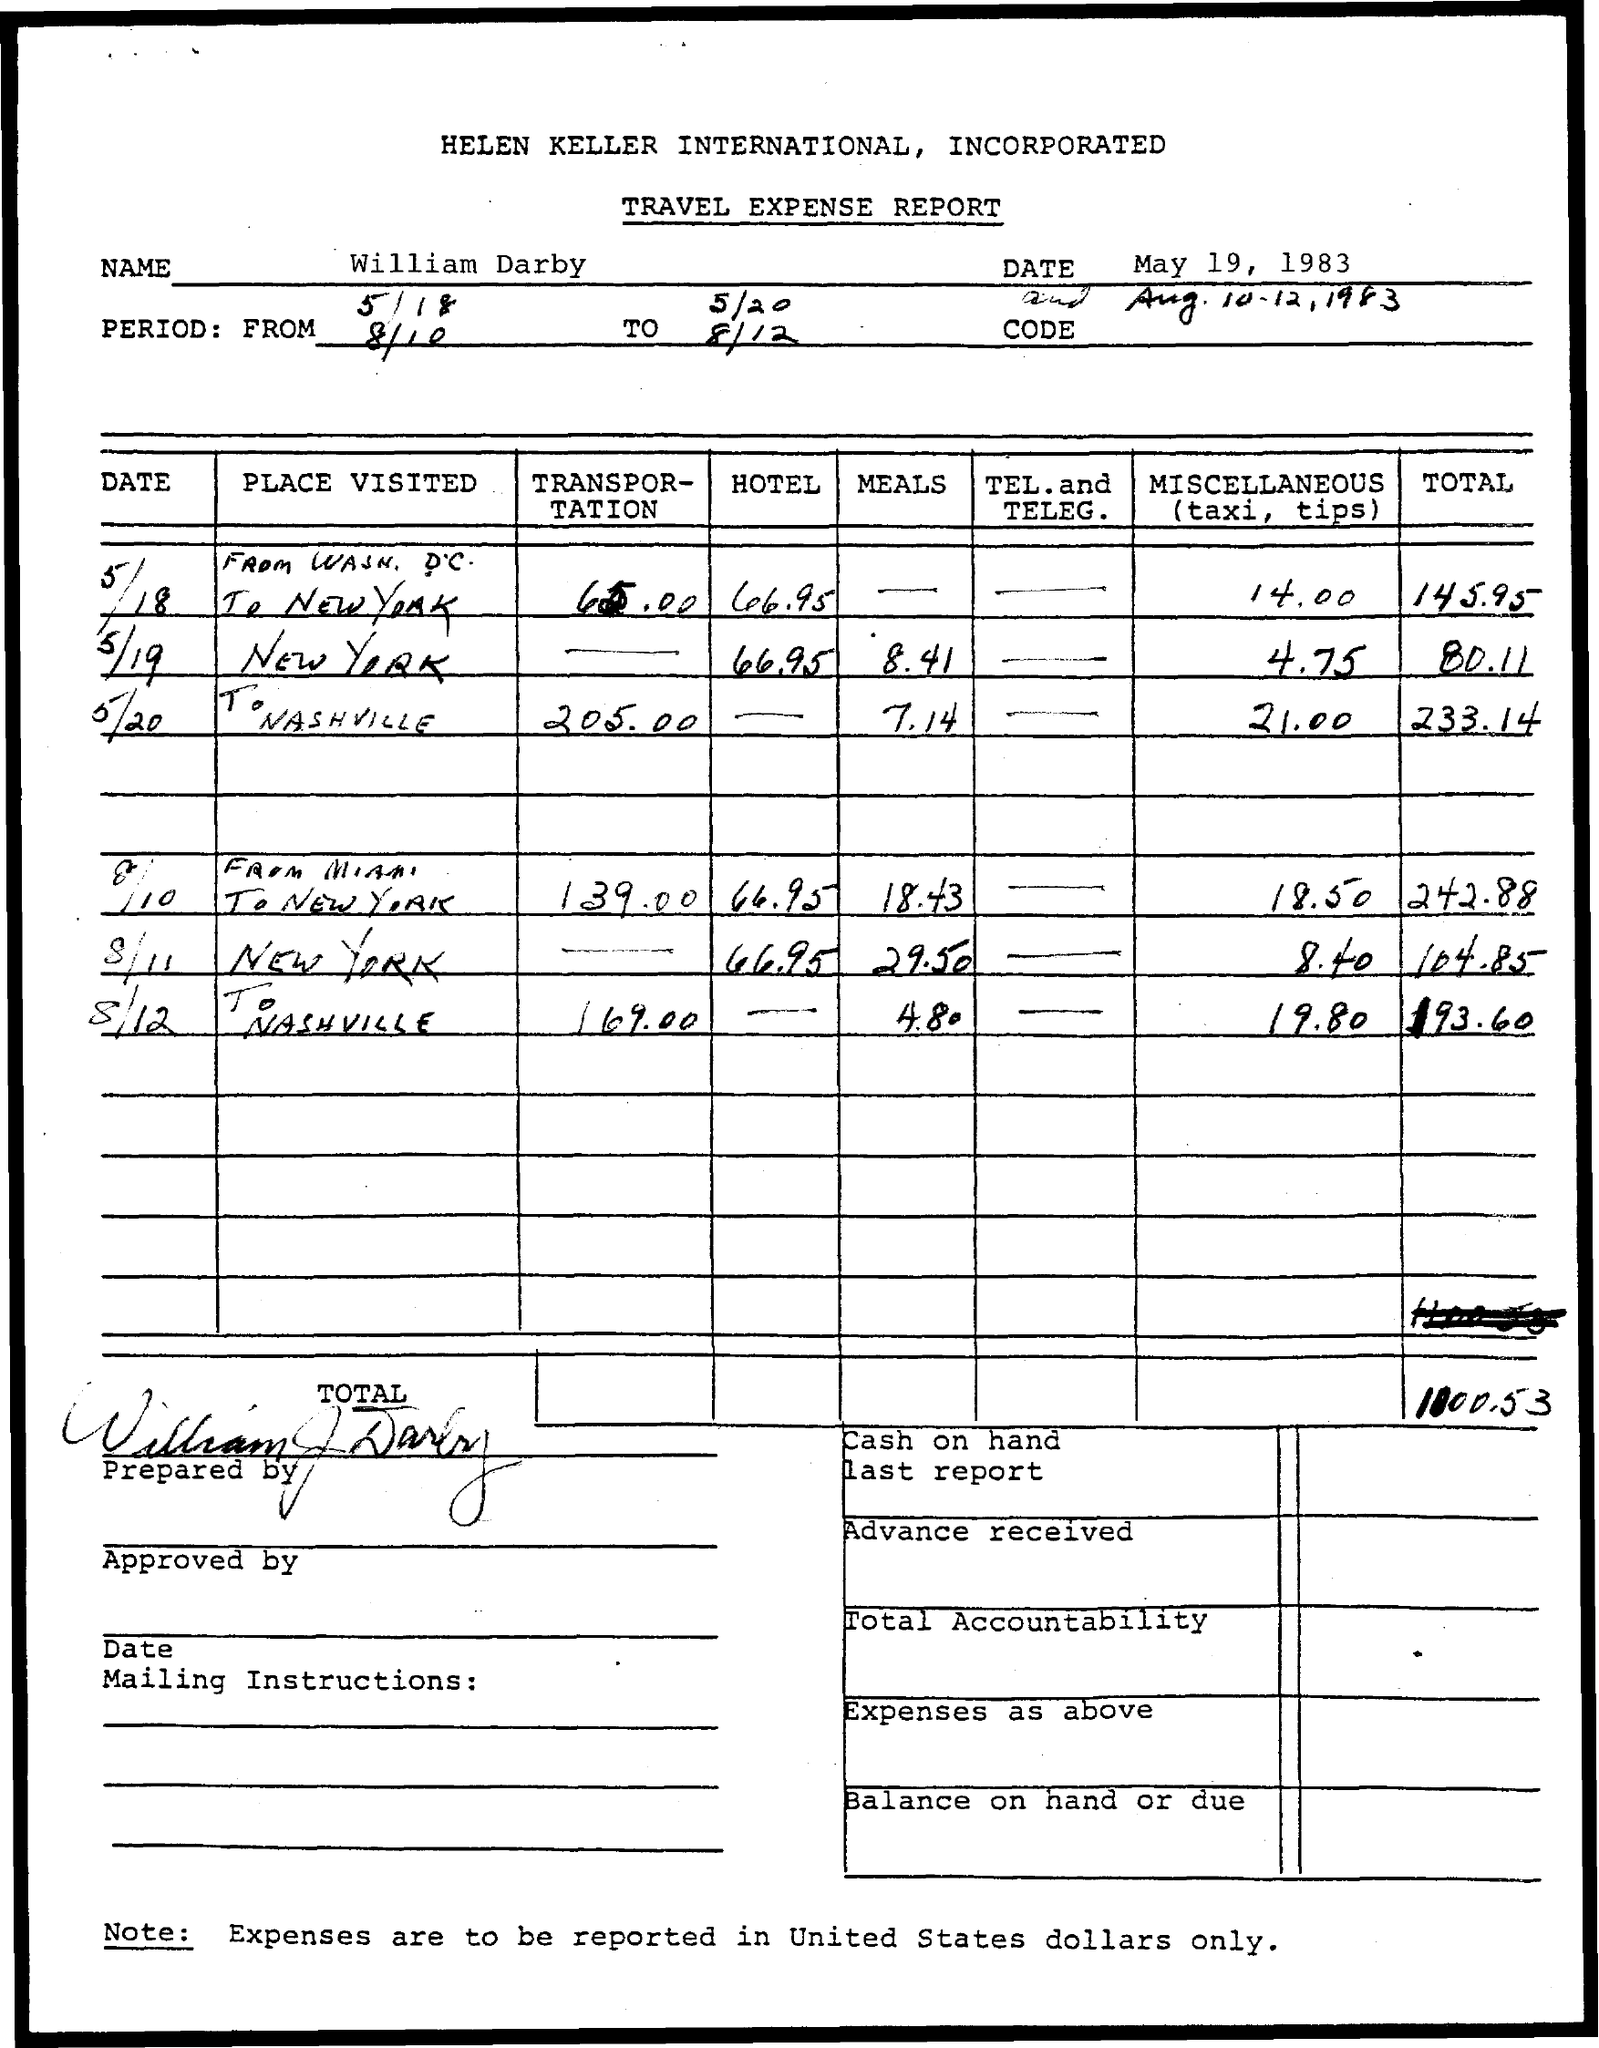Specify some key components in this picture. The person mentioned in the document is named William Darby. 